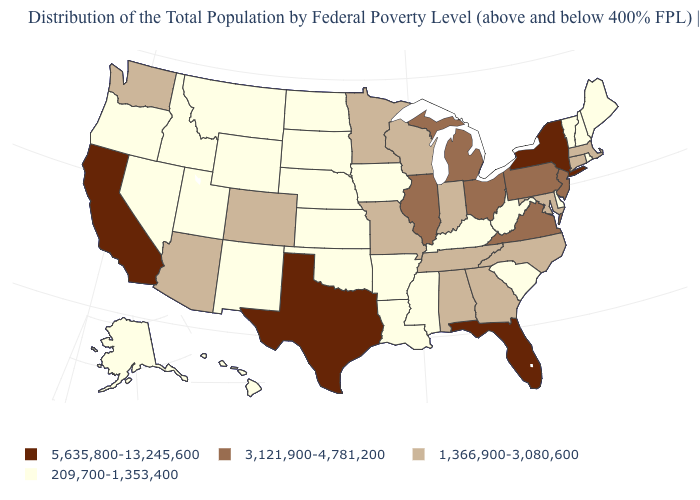Which states have the lowest value in the USA?
Short answer required. Alaska, Arkansas, Delaware, Hawaii, Idaho, Iowa, Kansas, Kentucky, Louisiana, Maine, Mississippi, Montana, Nebraska, Nevada, New Hampshire, New Mexico, North Dakota, Oklahoma, Oregon, Rhode Island, South Carolina, South Dakota, Utah, Vermont, West Virginia, Wyoming. What is the value of Montana?
Give a very brief answer. 209,700-1,353,400. What is the value of Delaware?
Write a very short answer. 209,700-1,353,400. What is the value of North Dakota?
Write a very short answer. 209,700-1,353,400. Name the states that have a value in the range 1,366,900-3,080,600?
Write a very short answer. Alabama, Arizona, Colorado, Connecticut, Georgia, Indiana, Maryland, Massachusetts, Minnesota, Missouri, North Carolina, Tennessee, Washington, Wisconsin. Which states have the lowest value in the South?
Concise answer only. Arkansas, Delaware, Kentucky, Louisiana, Mississippi, Oklahoma, South Carolina, West Virginia. What is the value of California?
Answer briefly. 5,635,800-13,245,600. Name the states that have a value in the range 209,700-1,353,400?
Short answer required. Alaska, Arkansas, Delaware, Hawaii, Idaho, Iowa, Kansas, Kentucky, Louisiana, Maine, Mississippi, Montana, Nebraska, Nevada, New Hampshire, New Mexico, North Dakota, Oklahoma, Oregon, Rhode Island, South Carolina, South Dakota, Utah, Vermont, West Virginia, Wyoming. Does California have the highest value in the West?
Be succinct. Yes. What is the lowest value in the USA?
Keep it brief. 209,700-1,353,400. Among the states that border Oregon , does California have the highest value?
Give a very brief answer. Yes. Name the states that have a value in the range 1,366,900-3,080,600?
Be succinct. Alabama, Arizona, Colorado, Connecticut, Georgia, Indiana, Maryland, Massachusetts, Minnesota, Missouri, North Carolina, Tennessee, Washington, Wisconsin. Does South Dakota have the highest value in the USA?
Concise answer only. No. Does Alabama have the lowest value in the USA?
Keep it brief. No. Is the legend a continuous bar?
Give a very brief answer. No. 